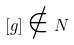Convert formula to latex. <formula><loc_0><loc_0><loc_500><loc_500>[ g ] \notin N</formula> 